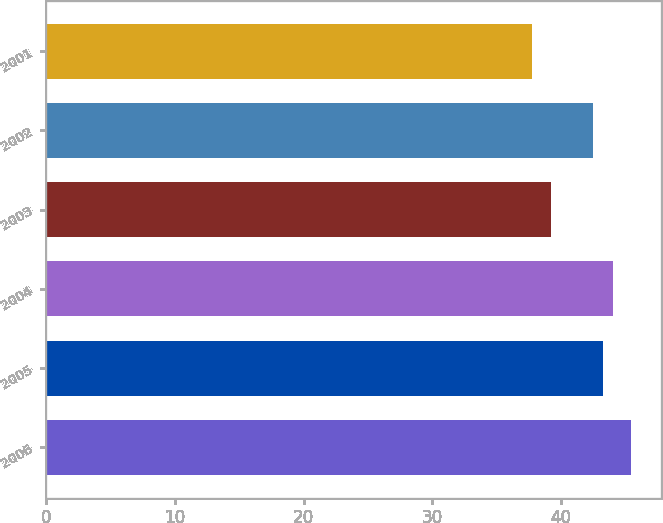Convert chart to OTSL. <chart><loc_0><loc_0><loc_500><loc_500><bar_chart><fcel>2006<fcel>2005<fcel>2004<fcel>2003<fcel>2002<fcel>2001<nl><fcel>45.46<fcel>43.28<fcel>44.05<fcel>39.23<fcel>42.51<fcel>37.75<nl></chart> 